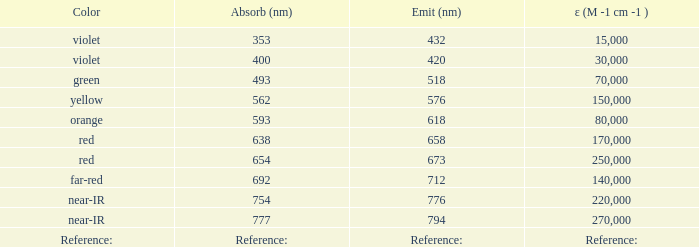Which emission (in nanometers) has a molecular weight of 1078 g/mol? 618.0. 